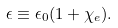<formula> <loc_0><loc_0><loc_500><loc_500>\epsilon \equiv \epsilon _ { 0 } ( 1 + \chi _ { e } ) .</formula> 